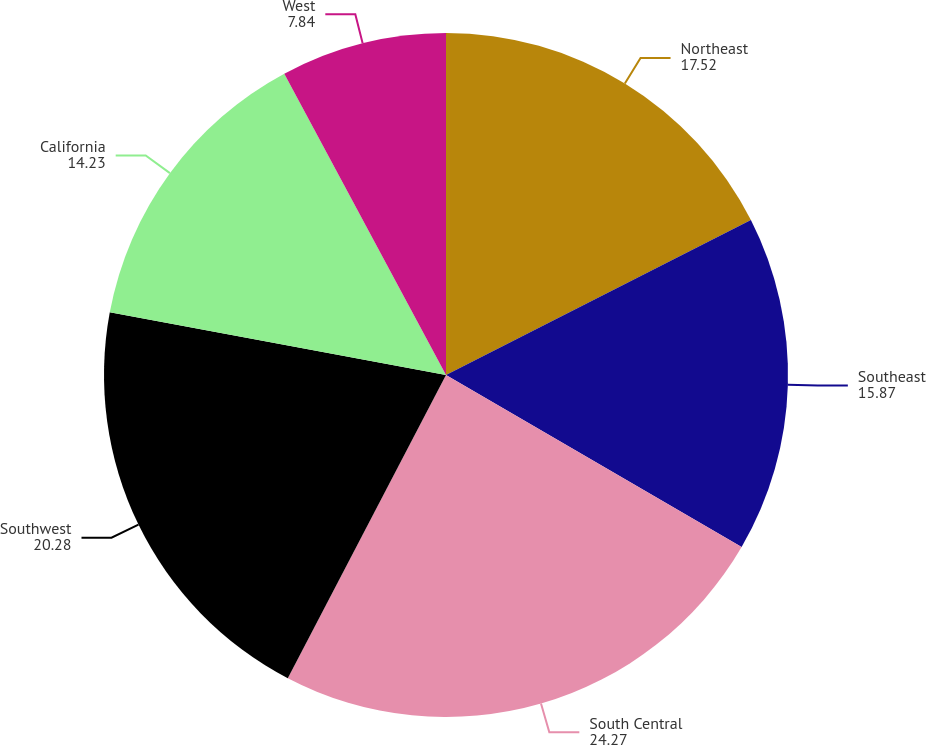Convert chart. <chart><loc_0><loc_0><loc_500><loc_500><pie_chart><fcel>Northeast<fcel>Southeast<fcel>South Central<fcel>Southwest<fcel>California<fcel>West<nl><fcel>17.52%<fcel>15.87%<fcel>24.27%<fcel>20.28%<fcel>14.23%<fcel>7.84%<nl></chart> 